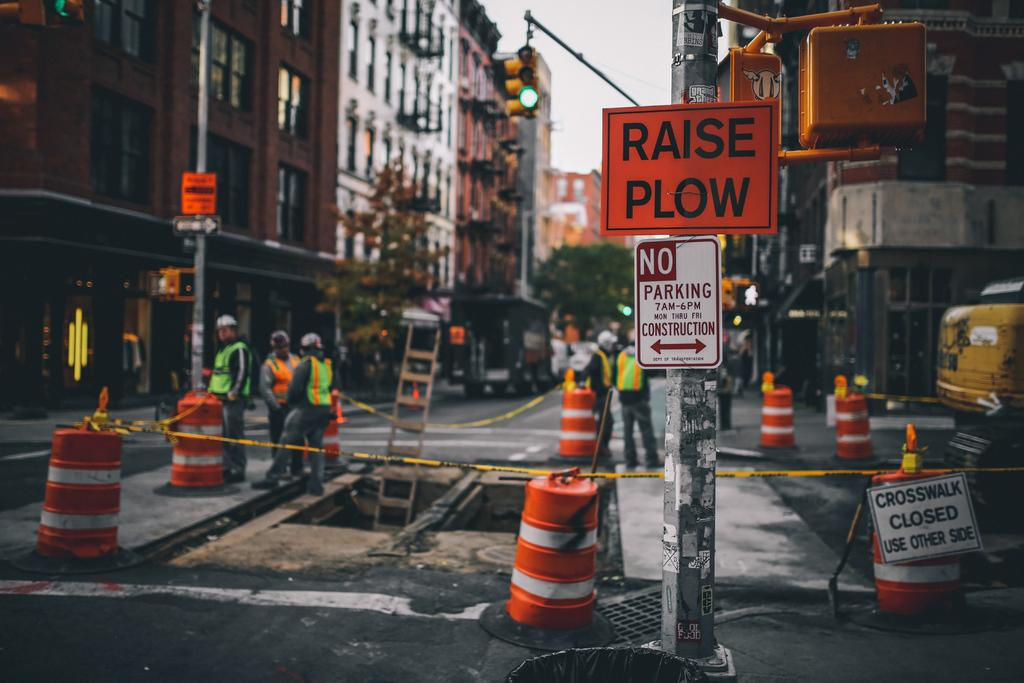Provide a one-sentence caption for the provided image. A orange and black raise plow sign is standing in front of a construction site. 